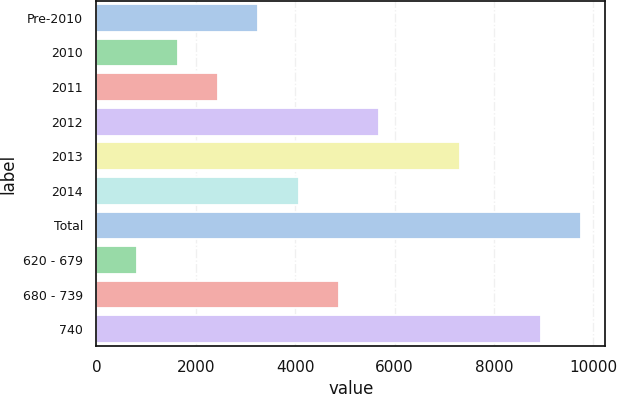Convert chart to OTSL. <chart><loc_0><loc_0><loc_500><loc_500><bar_chart><fcel>Pre-2010<fcel>2010<fcel>2011<fcel>2012<fcel>2013<fcel>2014<fcel>Total<fcel>620 - 679<fcel>680 - 739<fcel>740<nl><fcel>3261<fcel>1639<fcel>2450<fcel>5694<fcel>7316<fcel>4072<fcel>9749<fcel>828<fcel>4883<fcel>8938<nl></chart> 